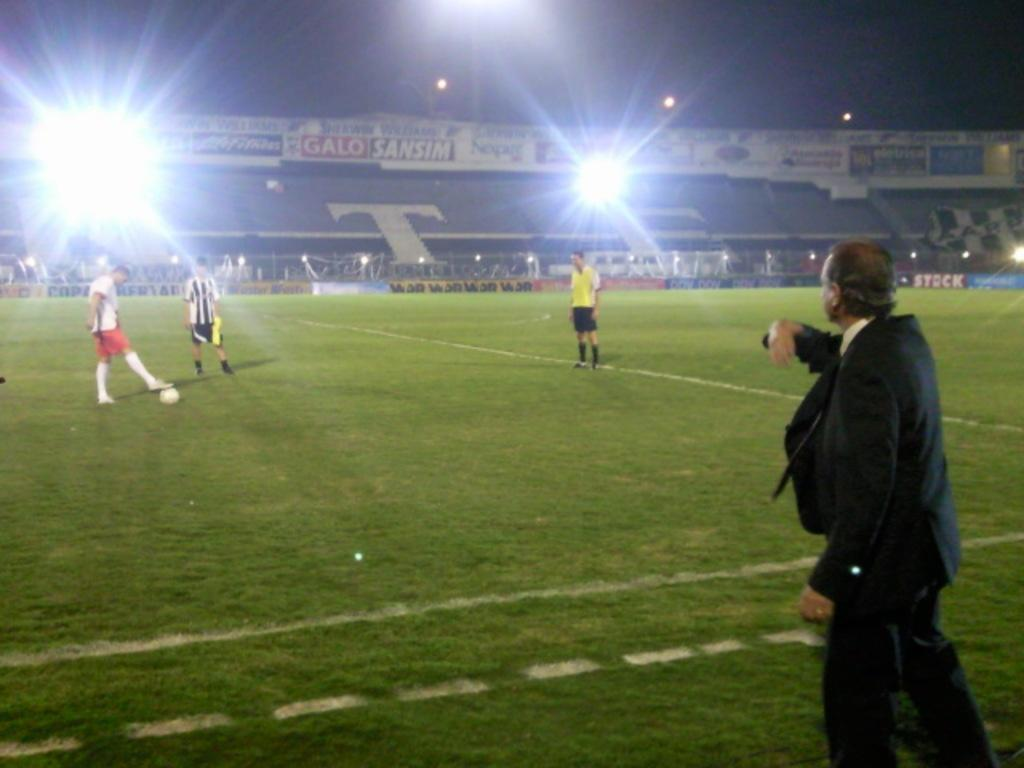<image>
Offer a succinct explanation of the picture presented. Players wait on the field while under an ad board for Sherwin Williams and Galo Sansim. 